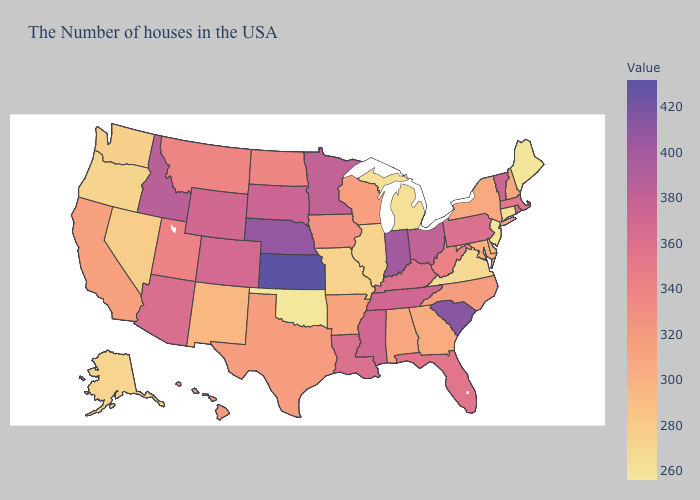Does South Dakota have the lowest value in the MidWest?
Give a very brief answer. No. Does Oklahoma have the lowest value in the South?
Write a very short answer. Yes. 